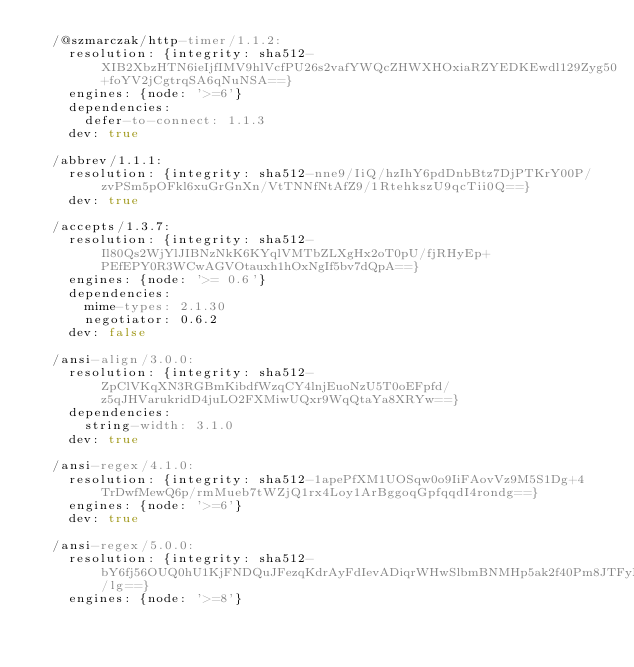Convert code to text. <code><loc_0><loc_0><loc_500><loc_500><_YAML_>  /@szmarczak/http-timer/1.1.2:
    resolution: {integrity: sha512-XIB2XbzHTN6ieIjfIMV9hlVcfPU26s2vafYWQcZHWXHOxiaRZYEDKEwdl129Zyg50+foYV2jCgtrqSA6qNuNSA==}
    engines: {node: '>=6'}
    dependencies:
      defer-to-connect: 1.1.3
    dev: true

  /abbrev/1.1.1:
    resolution: {integrity: sha512-nne9/IiQ/hzIhY6pdDnbBtz7DjPTKrY00P/zvPSm5pOFkl6xuGrGnXn/VtTNNfNtAfZ9/1RtehkszU9qcTii0Q==}
    dev: true

  /accepts/1.3.7:
    resolution: {integrity: sha512-Il80Qs2WjYlJIBNzNkK6KYqlVMTbZLXgHx2oT0pU/fjRHyEp+PEfEPY0R3WCwAGVOtauxh1hOxNgIf5bv7dQpA==}
    engines: {node: '>= 0.6'}
    dependencies:
      mime-types: 2.1.30
      negotiator: 0.6.2
    dev: false

  /ansi-align/3.0.0:
    resolution: {integrity: sha512-ZpClVKqXN3RGBmKibdfWzqCY4lnjEuoNzU5T0oEFpfd/z5qJHVarukridD4juLO2FXMiwUQxr9WqQtaYa8XRYw==}
    dependencies:
      string-width: 3.1.0
    dev: true

  /ansi-regex/4.1.0:
    resolution: {integrity: sha512-1apePfXM1UOSqw0o9IiFAovVz9M5S1Dg+4TrDwfMewQ6p/rmMueb7tWZjQ1rx4Loy1ArBggoqGpfqqdI4rondg==}
    engines: {node: '>=6'}
    dev: true

  /ansi-regex/5.0.0:
    resolution: {integrity: sha512-bY6fj56OUQ0hU1KjFNDQuJFezqKdrAyFdIevADiqrWHwSlbmBNMHp5ak2f40Pm8JTFyM2mqxkG6ngkHO11f/lg==}
    engines: {node: '>=8'}</code> 